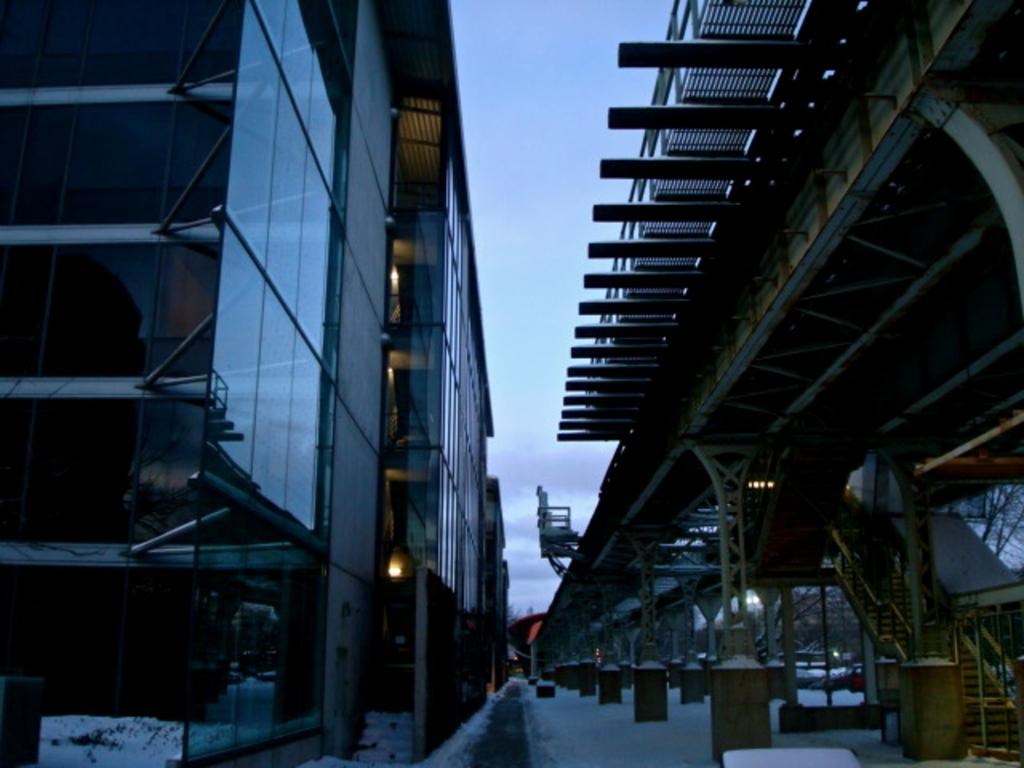What type of structures can be seen in the image? There are buildings in the image. What architectural feature is present in the image? There is a staircase in the image. What safety feature is included in the image? Railings are present in the image. What is the condition of the road in the image? Snow is visible on the road. What is visible in the background of the image? The sky is visible in the image, and clouds are present in the sky. What type of skirt is hanging on the railing in the image? There is no skirt present in the image; only buildings, a staircase, railings, snow, and the sky are visible. Is there a tent set up in the snow in the image? There is no tent present in the image; only buildings, a staircase, railings, snow, and the sky are visible. 